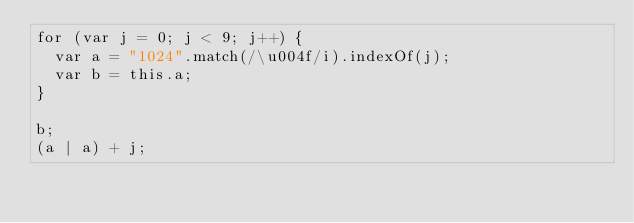Convert code to text. <code><loc_0><loc_0><loc_500><loc_500><_JavaScript_>for (var j = 0; j < 9; j++) {
  var a = "1024".match(/\u004f/i).indexOf(j);
  var b = this.a;
}

b;
(a | a) + j;
</code> 